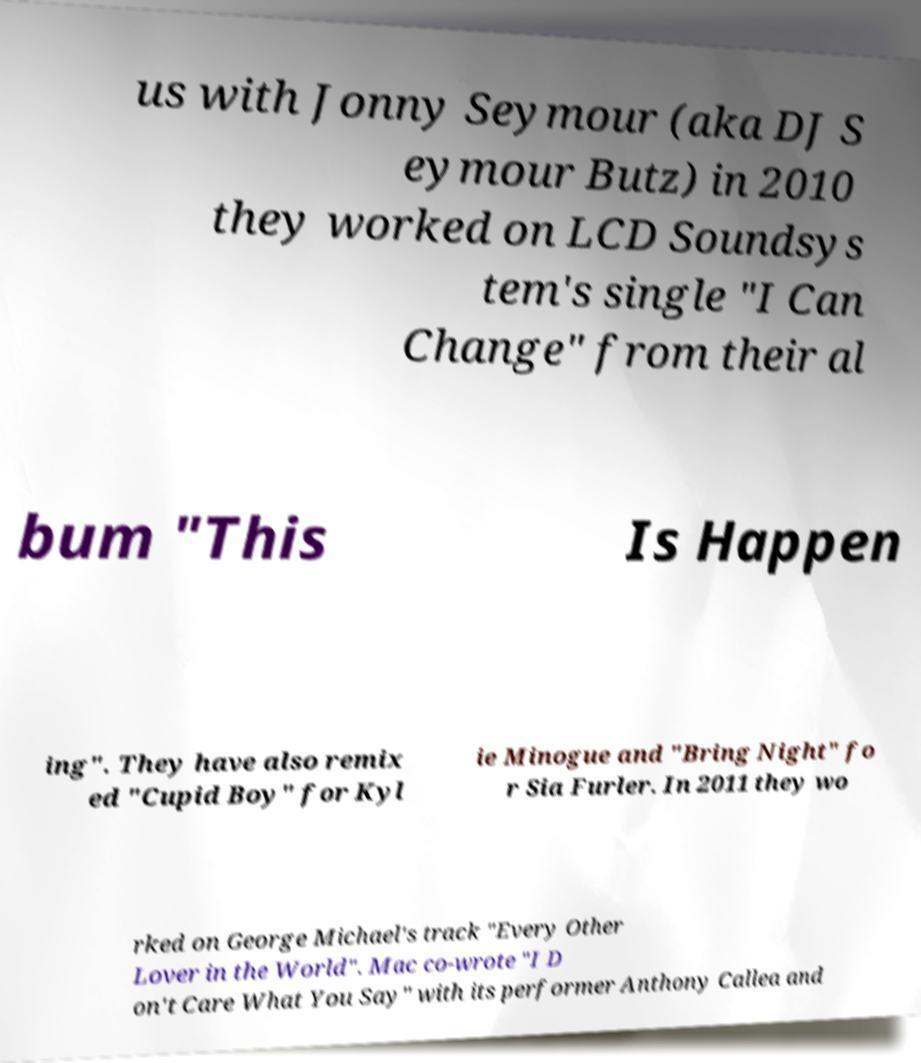Can you read and provide the text displayed in the image?This photo seems to have some interesting text. Can you extract and type it out for me? us with Jonny Seymour (aka DJ S eymour Butz) in 2010 they worked on LCD Soundsys tem's single "I Can Change" from their al bum "This Is Happen ing". They have also remix ed "Cupid Boy" for Kyl ie Minogue and "Bring Night" fo r Sia Furler. In 2011 they wo rked on George Michael's track "Every Other Lover in the World". Mac co-wrote "I D on't Care What You Say" with its performer Anthony Callea and 